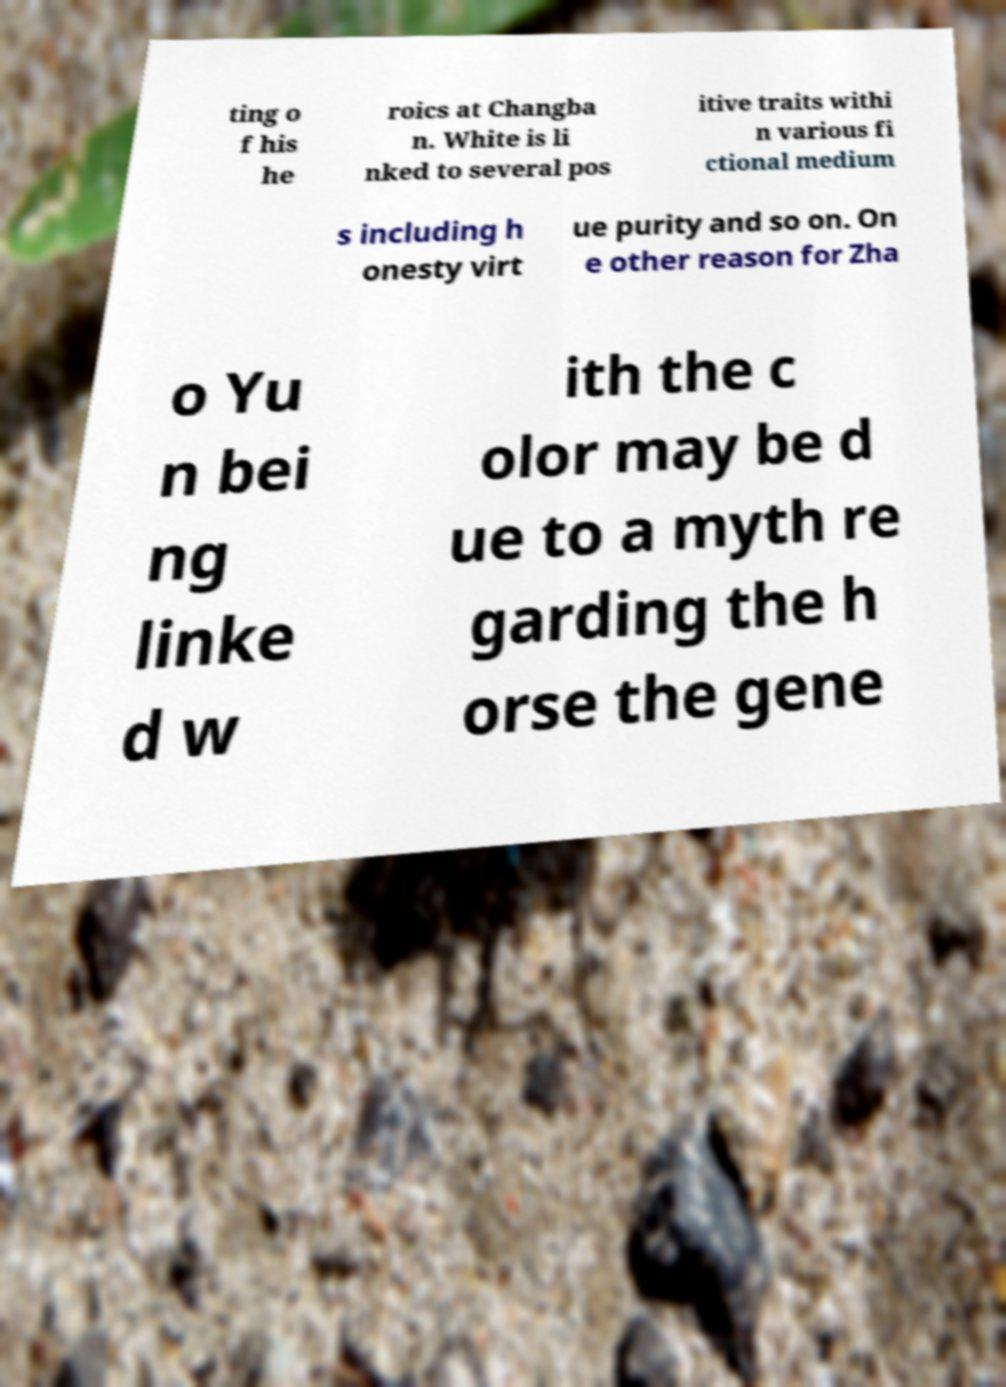I need the written content from this picture converted into text. Can you do that? ting o f his he roics at Changba n. White is li nked to several pos itive traits withi n various fi ctional medium s including h onesty virt ue purity and so on. On e other reason for Zha o Yu n bei ng linke d w ith the c olor may be d ue to a myth re garding the h orse the gene 